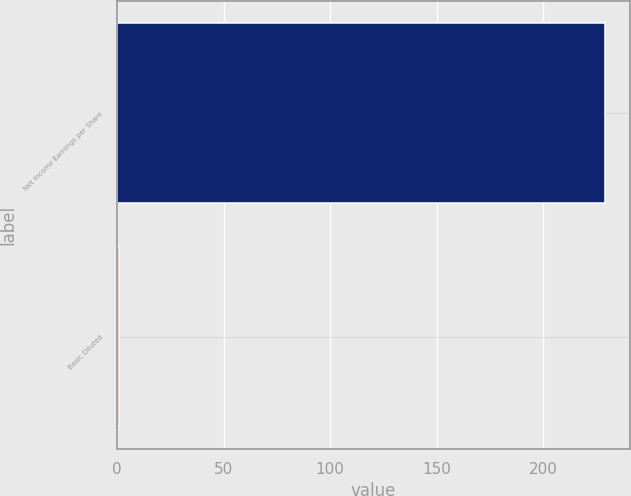<chart> <loc_0><loc_0><loc_500><loc_500><bar_chart><fcel>Net Income Earnings per Share<fcel>Basic Diluted<nl><fcel>229<fcel>1.06<nl></chart> 